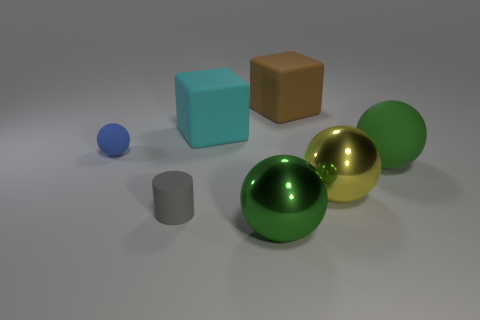How many big metallic objects are the same color as the large rubber ball?
Give a very brief answer. 1. What material is the other big ball that is the same color as the big rubber ball?
Provide a succinct answer. Metal. Are there more large brown objects that are in front of the big brown cube than green matte spheres?
Give a very brief answer. No. Is the small gray matte thing the same shape as the large green rubber object?
Offer a very short reply. No. What number of tiny gray objects are made of the same material as the yellow ball?
Your answer should be very brief. 0. The blue matte thing that is the same shape as the green metallic object is what size?
Offer a very short reply. Small. Does the yellow metal sphere have the same size as the brown matte block?
Your response must be concise. Yes. What is the shape of the small blue thing on the left side of the large thing that is to the left of the large thing in front of the gray thing?
Ensure brevity in your answer.  Sphere. The other rubber thing that is the same shape as the cyan object is what color?
Your response must be concise. Brown. What is the size of the matte object that is in front of the tiny blue matte ball and on the right side of the large green shiny sphere?
Your answer should be compact. Large. 